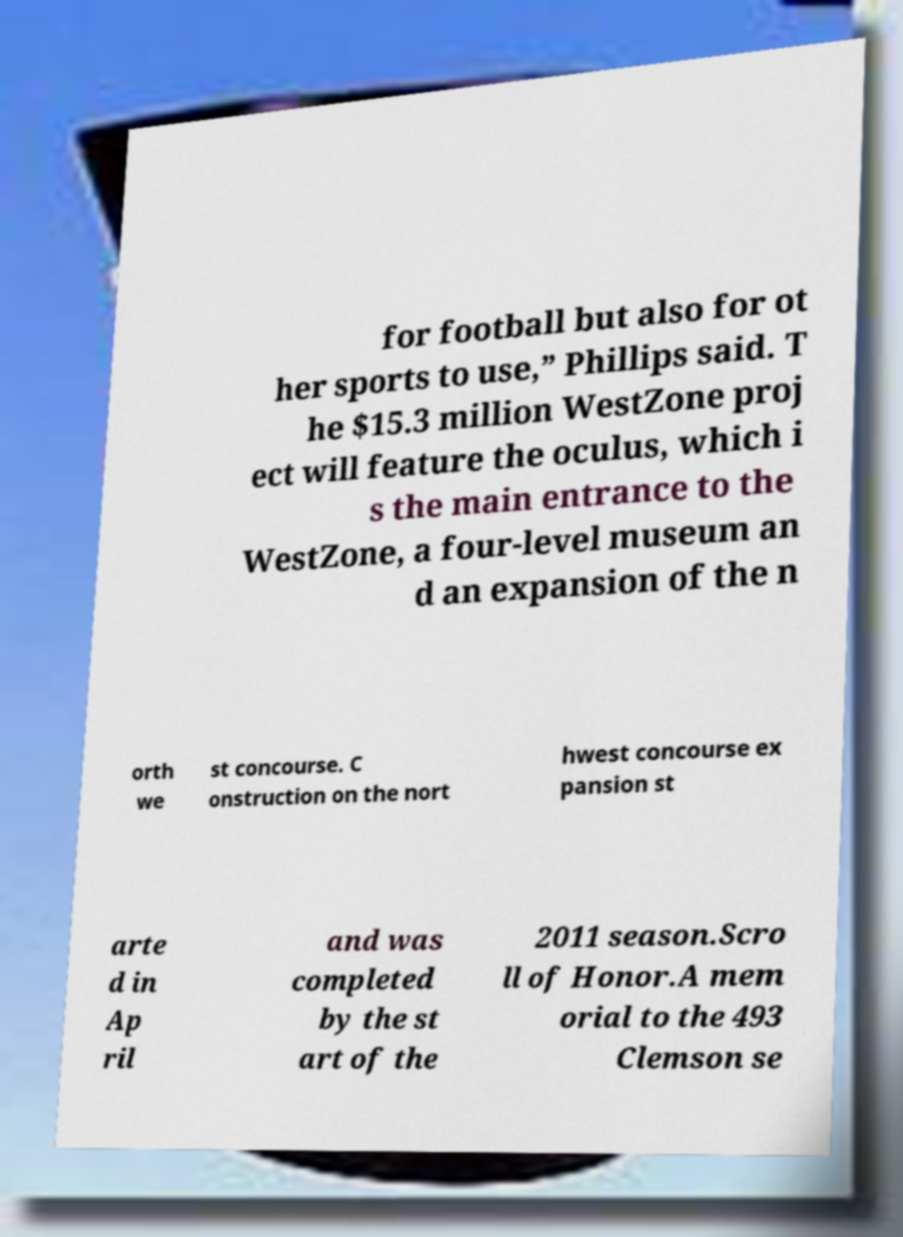There's text embedded in this image that I need extracted. Can you transcribe it verbatim? for football but also for ot her sports to use,” Phillips said. T he $15.3 million WestZone proj ect will feature the oculus, which i s the main entrance to the WestZone, a four-level museum an d an expansion of the n orth we st concourse. C onstruction on the nort hwest concourse ex pansion st arte d in Ap ril and was completed by the st art of the 2011 season.Scro ll of Honor.A mem orial to the 493 Clemson se 